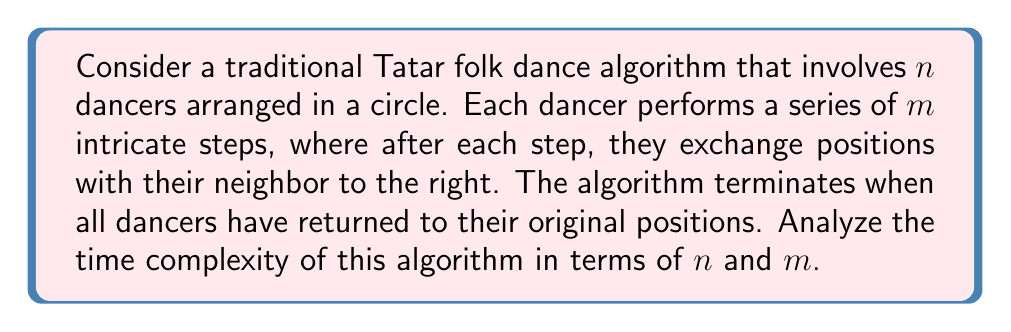Give your solution to this math problem. Let's break down the algorithm and analyze its time complexity:

1. Initial setup: Arranging $n$ dancers in a circle takes $O(n)$ time.

2. Dance steps:
   - Each dancer performs $m$ steps: $O(m)$
   - After each step, dancers exchange positions: $O(1)$
   - This process is repeated for all $n$ dancers: $O(n)$

3. Termination condition:
   - The dance continues until all dancers return to their original positions.
   - This is equivalent to a circular rotation, which completes after $n$ iterations.

4. Total iterations:
   - The outer loop (rotations) runs $n$ times
   - The inner loop (steps per dancer) runs $m$ times

5. Time complexity analysis:
   $$T(n,m) = O(n) + O(n \cdot n \cdot m)$$
   
   The initial setup $O(n)$ is dominated by the main algorithm, so we can simplify to:
   $$T(n,m) = O(n^2 \cdot m)$$

This quadratic time complexity in terms of $n$ arises because:
a) We need $n$ rotations to complete the dance
b) Each rotation involves $n$ dancers
c) Each dancer performs $m$ steps in every rotation

The algorithm's efficiency could be improved by optimizing the rotation mechanism, but given the traditional nature of the dance, we assume this algorithm preserves the authentic steps and interactions.
Answer: The time complexity of the traditional Tatar folk dance algorithm is $O(n^2 \cdot m)$, where $n$ is the number of dancers and $m$ is the number of steps each dancer performs. 